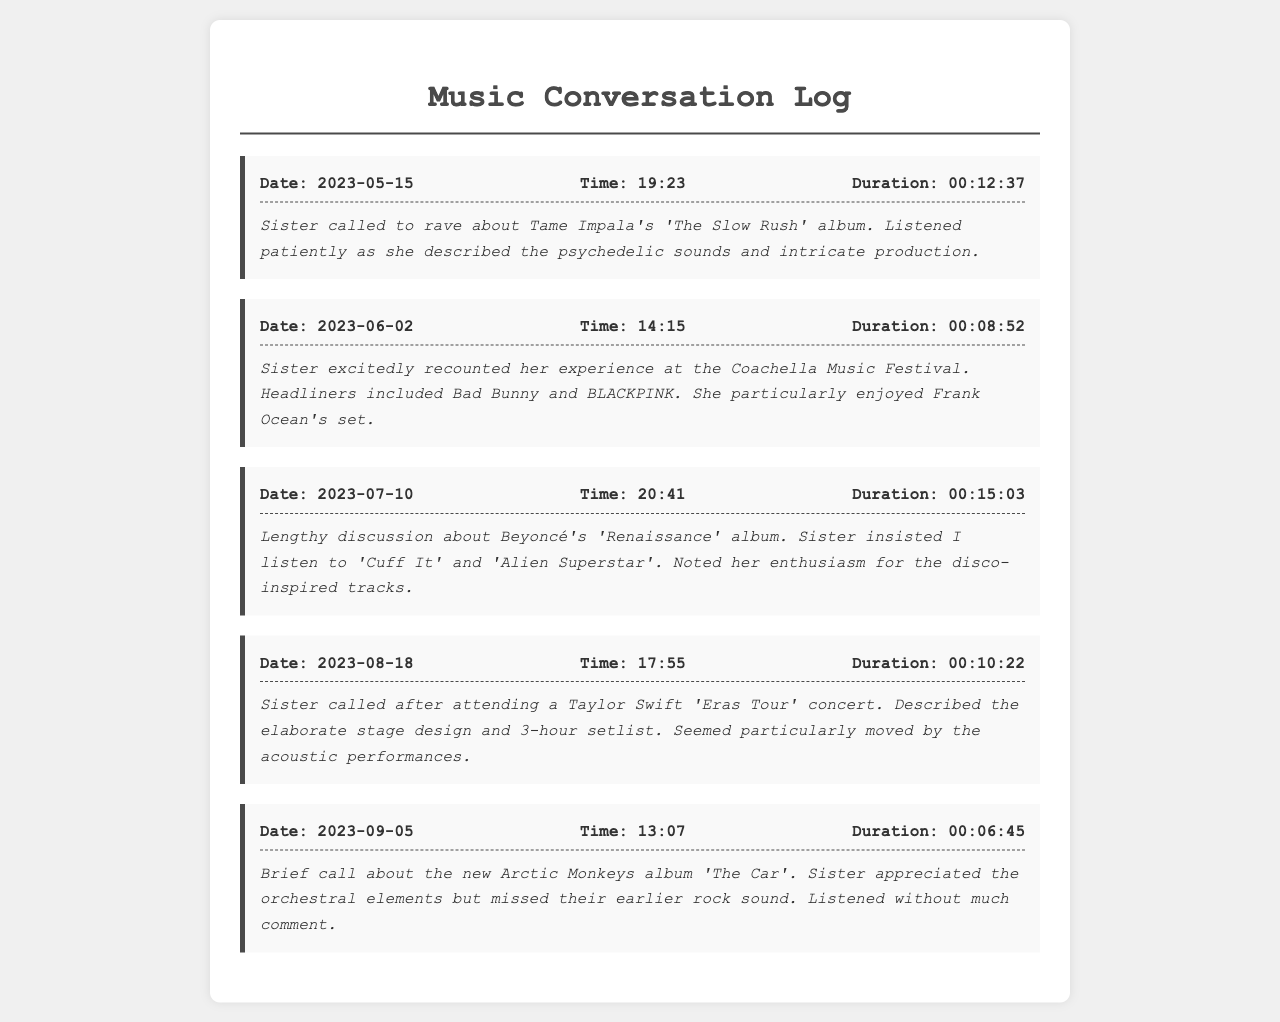What was the date of the call about Tame Impala's album? The call about Tame Impala's album took place on May 15, 2023.
Answer: May 15, 2023 Who did your sister see at Coachella? The call mentions her excitement about Bad Bunny and BLACKPINK being headliners, along with Frank Ocean's set.
Answer: Bad Bunny and BLACKPINK Which album was discussed on July 10, 2023? The call log indicates a discussion about Beyoncé's album 'Renaissance'.
Answer: 'Renaissance' What song did your sister insist you listen to from the 'Renaissance' album? The call notes specify two songs she insisted on: 'Cuff It' and 'Alien Superstar'.
Answer: 'Cuff It' and 'Alien Superstar' What impressed your sister most about the 'Eras Tour' concert? The log notes that she was particularly moved by the acoustic performances during the Taylor Swift concert.
Answer: Acoustic performances How long was the call about the new Arctic Monkeys album? The duration of the call concerning Arctic Monkeys' album 'The Car' is recorded as 6 minutes and 45 seconds.
Answer: 00:06:45 What elements did your sister appreciate in the Arctic Monkeys album? The sister appreciated the orchestral elements in 'The Car' but missed their earlier rock sound.
Answer: Orchestral elements When did the sister call to talk about her concert experience? The call is logged on August 18, 2023, detailing her experience at the Taylor Swift concert.
Answer: August 18, 2023 